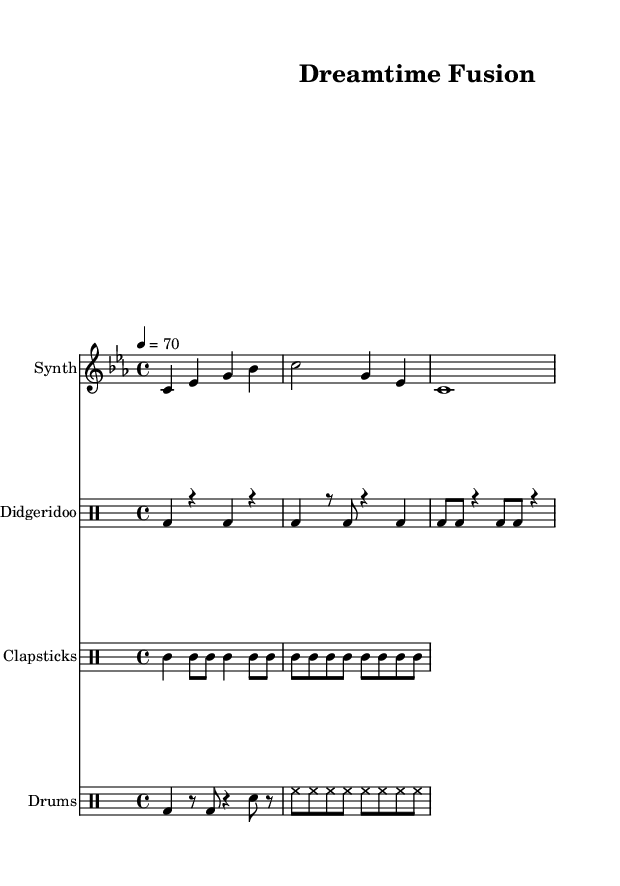What is the key signature of this music? The key signature is C minor, which has three flats (B flat, E flat, A flat). This is indicated at the beginning of the staff.
Answer: C minor What is the time signature of this piece? The time signature is 4/4, shown at the beginning of the score. This means there are four beats in each measure, and the quarter note gets one beat.
Answer: 4/4 What is the tempo marking indicated in the music? The tempo marking is 4 = 70, which tells the performer to play at a speed of 70 beats per minute using a quarter note as the beat.
Answer: 70 How many distinct instruments are featured in the score? Upon examining the score, there are four distinct instruments: Synth, Didgeridoo, Clapsticks, and Drums. Each has its own staff.
Answer: Four What type of musical texture is primarily used in this composition? The music features a polyphonic texture where multiple independent melodies and rhythms are played simultaneously from different instruments, such as the didgeridoo and clapsticks.
Answer: Polyphonic What rhythmic pattern is predominant in the didgeridoo part? The didgeridoo part predominantly uses a combination of bass drum strikes, signified by "bd," and rests, creating a rhythmic pattern that emphasizes strong and weak beats.
Answer: Bass drum strikes and rests How do the clapsticks contribute to the overall rhythm of the piece? The clapsticks maintain a steady, consistent rhythm throughout the piece, using both quarter notes and eighth notes to punctuate the larger rhythmic structure created by the other instruments, thus providing a rhythmic foundation.
Answer: Steady, consistent rhythm 